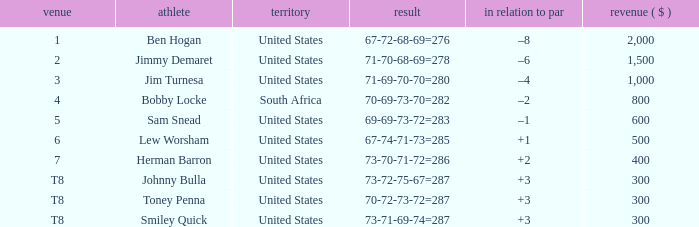What is the To par of the 4 Place Player? –2. 